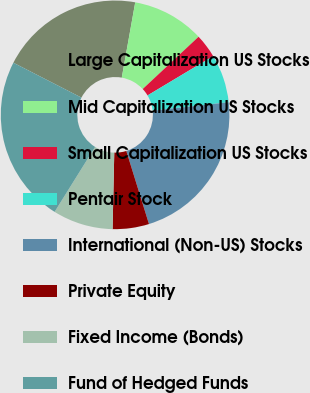Convert chart to OTSL. <chart><loc_0><loc_0><loc_500><loc_500><pie_chart><fcel>Large Capitalization US Stocks<fcel>Mid Capitalization US Stocks<fcel>Small Capitalization US Stocks<fcel>Pentair Stock<fcel>International (Non-US) Stocks<fcel>Private Equity<fcel>Fixed Income (Bonds)<fcel>Fund of Hedged Funds<nl><fcel>20.28%<fcel>10.21%<fcel>3.38%<fcel>6.83%<fcel>21.97%<fcel>5.14%<fcel>8.52%<fcel>23.66%<nl></chart> 